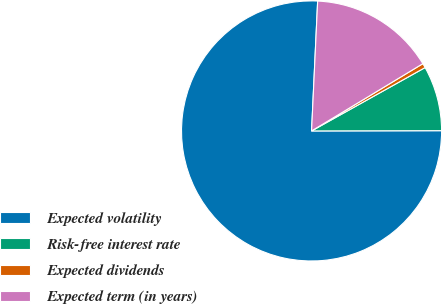Convert chart. <chart><loc_0><loc_0><loc_500><loc_500><pie_chart><fcel>Expected volatility<fcel>Risk-free interest rate<fcel>Expected dividends<fcel>Expected term (in years)<nl><fcel>75.78%<fcel>8.07%<fcel>0.55%<fcel>15.6%<nl></chart> 